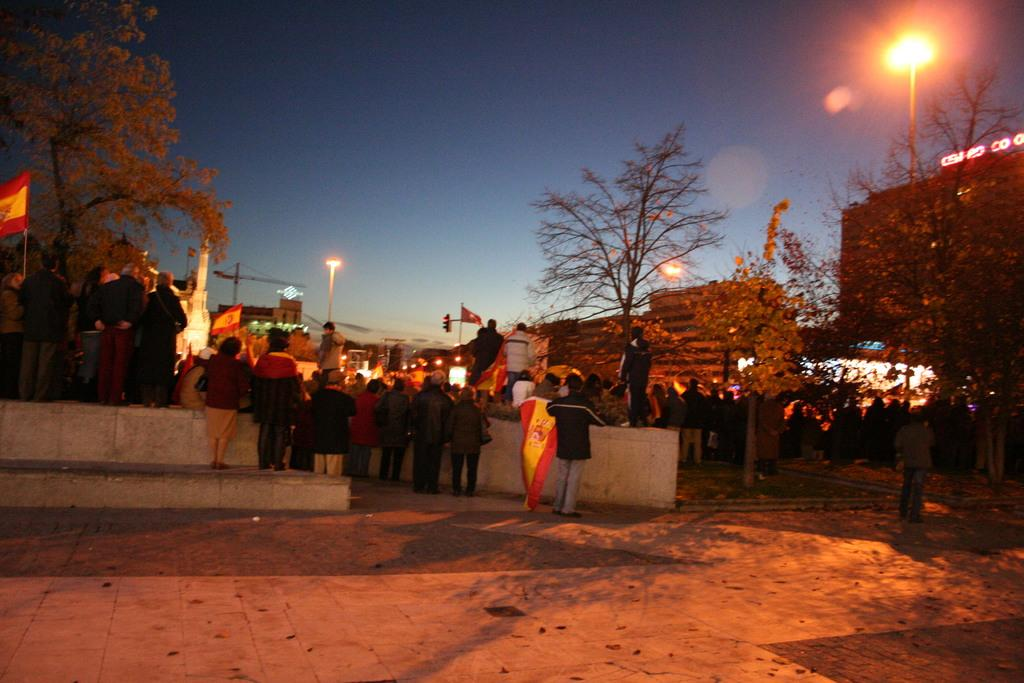How many people are in the image? There is a group of people in the image, but the exact number cannot be determined from the provided facts. What are some people doing in the image? Some people are holding flags in the image. What can be seen in the background of the image? There are trees, houses, lights, poles, and a crane visible in the background of the image. What type of milk is being served at the border in the image? There is no mention of a border or milk in the image; it features a group of people and various background elements. 